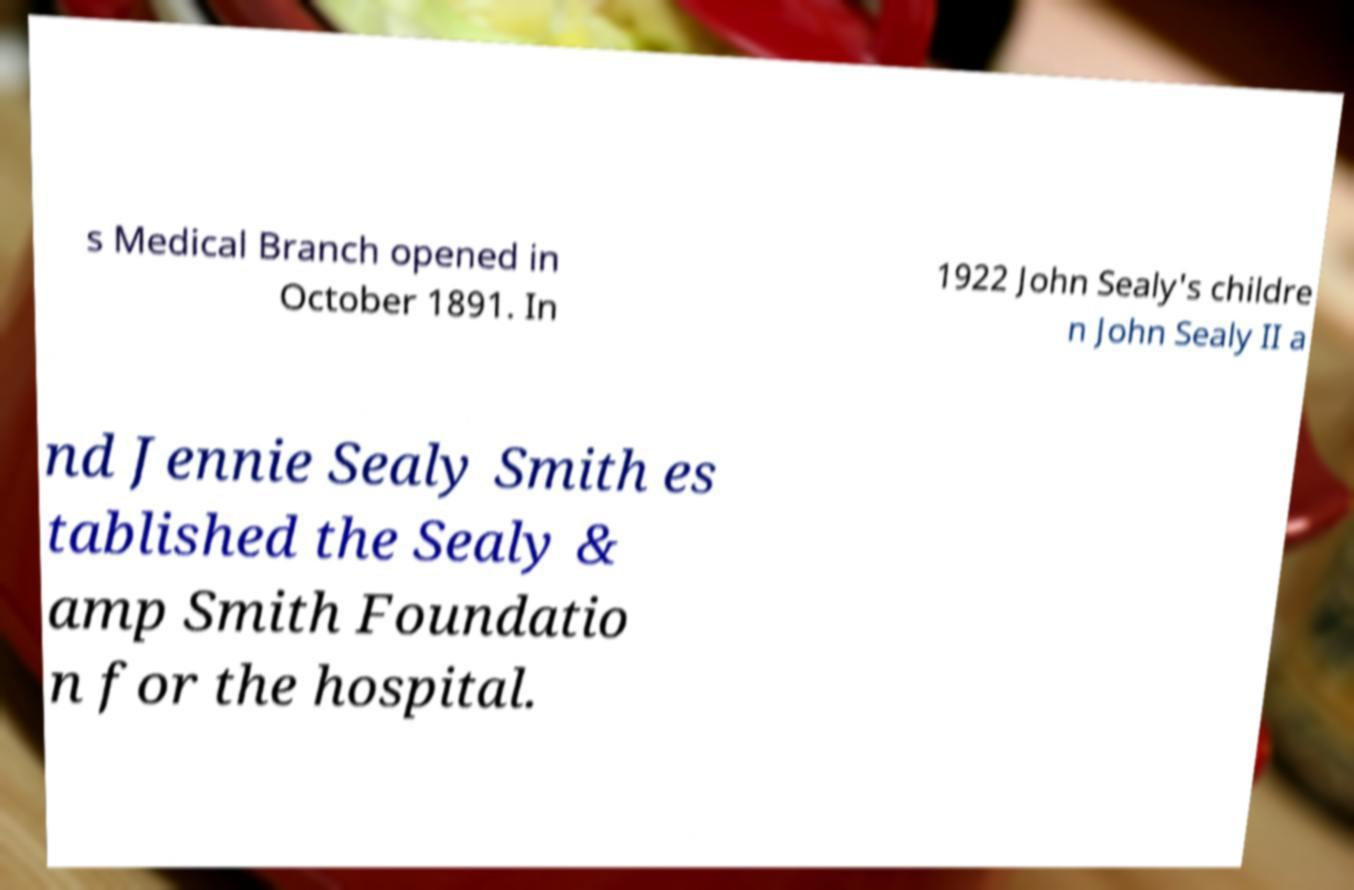Could you extract and type out the text from this image? s Medical Branch opened in October 1891. In 1922 John Sealy's childre n John Sealy II a nd Jennie Sealy Smith es tablished the Sealy & amp Smith Foundatio n for the hospital. 